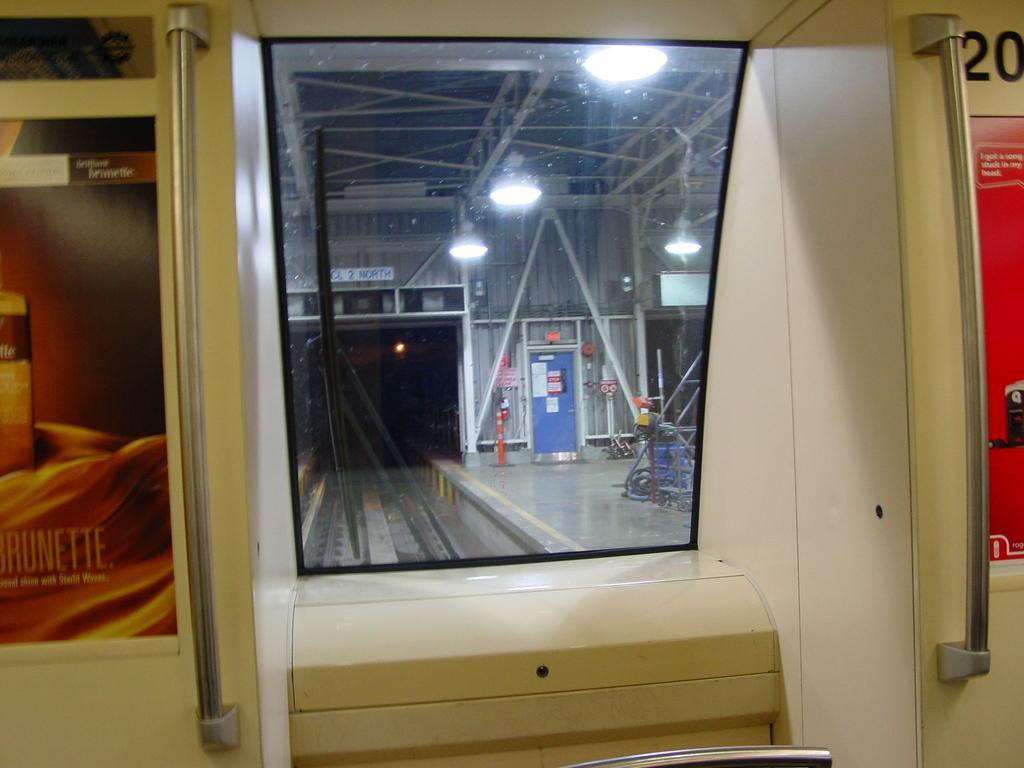Describe this image in one or two sentences. This looks like a glass window. These are the hangers. These look like posters, which are attached to the board. I think this is the rail track. I can see the lights hanging to the roof. I can see few objects placed on the platform. 